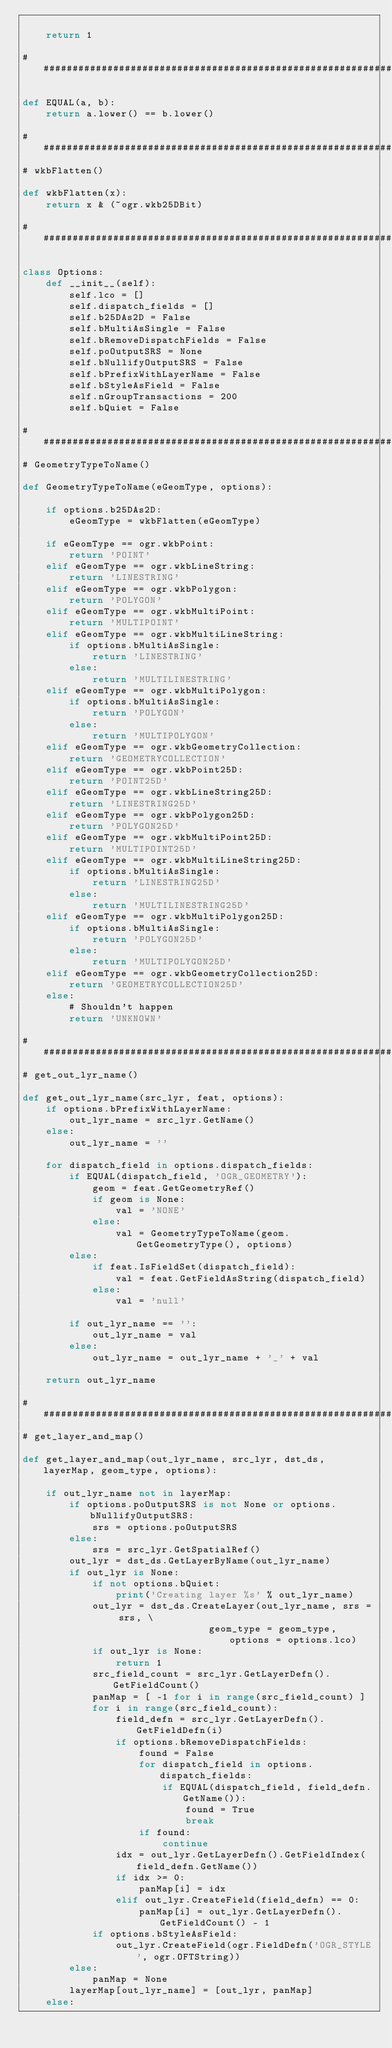<code> <loc_0><loc_0><loc_500><loc_500><_Python_>
    return 1

###############################################################################

def EQUAL(a, b):
    return a.lower() == b.lower()

###############################################################
# wkbFlatten()

def wkbFlatten(x):
    return x & (~ogr.wkb25DBit)

###############################################################

class Options:
    def __init__(self):
        self.lco = []
        self.dispatch_fields = []
        self.b25DAs2D = False
        self.bMultiAsSingle = False
        self.bRemoveDispatchFields = False
        self.poOutputSRS = None
        self.bNullifyOutputSRS = False
        self.bPrefixWithLayerName = False
        self.bStyleAsField = False
        self.nGroupTransactions = 200
        self.bQuiet = False

###############################################################
# GeometryTypeToName()

def GeometryTypeToName(eGeomType, options):

    if options.b25DAs2D:
        eGeomType = wkbFlatten(eGeomType)

    if eGeomType == ogr.wkbPoint:
        return 'POINT'
    elif eGeomType == ogr.wkbLineString:
        return 'LINESTRING'
    elif eGeomType == ogr.wkbPolygon:
        return 'POLYGON'
    elif eGeomType == ogr.wkbMultiPoint:
        return 'MULTIPOINT'
    elif eGeomType == ogr.wkbMultiLineString:
        if options.bMultiAsSingle:
            return 'LINESTRING'
        else:
            return 'MULTILINESTRING'
    elif eGeomType == ogr.wkbMultiPolygon:
        if options.bMultiAsSingle:
            return 'POLYGON'
        else:
            return 'MULTIPOLYGON'
    elif eGeomType == ogr.wkbGeometryCollection:
        return 'GEOMETRYCOLLECTION'
    elif eGeomType == ogr.wkbPoint25D:
        return 'POINT25D'
    elif eGeomType == ogr.wkbLineString25D:
        return 'LINESTRING25D'
    elif eGeomType == ogr.wkbPolygon25D:
        return 'POLYGON25D'
    elif eGeomType == ogr.wkbMultiPoint25D:
        return 'MULTIPOINT25D'
    elif eGeomType == ogr.wkbMultiLineString25D:
        if options.bMultiAsSingle:
            return 'LINESTRING25D'
        else:
            return 'MULTILINESTRING25D'
    elif eGeomType == ogr.wkbMultiPolygon25D:
        if options.bMultiAsSingle:
            return 'POLYGON25D'
        else:
            return 'MULTIPOLYGON25D'
    elif eGeomType == ogr.wkbGeometryCollection25D:
        return 'GEOMETRYCOLLECTION25D'
    else:
        # Shouldn't happen
        return 'UNKNOWN'

###############################################################
# get_out_lyr_name()

def get_out_lyr_name(src_lyr, feat, options):
    if options.bPrefixWithLayerName:
        out_lyr_name = src_lyr.GetName()
    else:
        out_lyr_name = ''

    for dispatch_field in options.dispatch_fields:
        if EQUAL(dispatch_field, 'OGR_GEOMETRY'):
            geom = feat.GetGeometryRef()
            if geom is None:
                val = 'NONE'
            else:
                val = GeometryTypeToName(geom.GetGeometryType(), options)
        else:
            if feat.IsFieldSet(dispatch_field):
                val = feat.GetFieldAsString(dispatch_field)
            else:
                val = 'null'

        if out_lyr_name == '':
            out_lyr_name = val
        else:
            out_lyr_name = out_lyr_name + '_' + val

    return out_lyr_name

###############################################################
# get_layer_and_map()

def get_layer_and_map(out_lyr_name, src_lyr, dst_ds, layerMap, geom_type, options):

    if out_lyr_name not in layerMap:
        if options.poOutputSRS is not None or options.bNullifyOutputSRS:
            srs = options.poOutputSRS
        else:
            srs = src_lyr.GetSpatialRef()
        out_lyr = dst_ds.GetLayerByName(out_lyr_name)
        if out_lyr is None:
            if not options.bQuiet:
                print('Creating layer %s' % out_lyr_name)
            out_lyr = dst_ds.CreateLayer(out_lyr_name, srs = srs, \
                                geom_type = geom_type, options = options.lco)
            if out_lyr is None:
                return 1
            src_field_count = src_lyr.GetLayerDefn().GetFieldCount()
            panMap = [ -1 for i in range(src_field_count) ]
            for i in range(src_field_count):
                field_defn = src_lyr.GetLayerDefn().GetFieldDefn(i)
                if options.bRemoveDispatchFields:
                    found = False
                    for dispatch_field in options.dispatch_fields:
                        if EQUAL(dispatch_field, field_defn.GetName()):
                            found = True
                            break
                    if found:
                        continue
                idx = out_lyr.GetLayerDefn().GetFieldIndex(field_defn.GetName())
                if idx >= 0:
                    panMap[i] = idx
                elif out_lyr.CreateField(field_defn) == 0:
                    panMap[i] = out_lyr.GetLayerDefn().GetFieldCount() - 1
            if options.bStyleAsField:
                out_lyr.CreateField(ogr.FieldDefn('OGR_STYLE', ogr.OFTString))
        else:
            panMap = None
        layerMap[out_lyr_name] = [out_lyr, panMap]
    else:</code> 